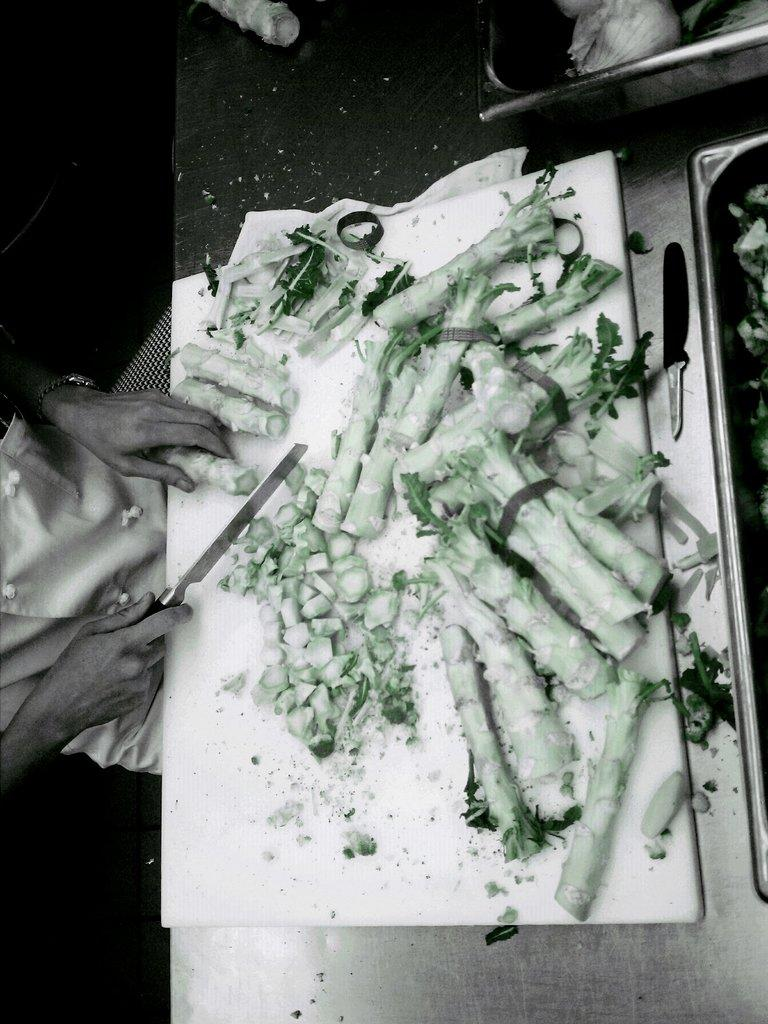What is the person in the image doing? The person is cutting vegetables. What surface is the person using to cut the vegetables? The vegetables are on a cutting board. Where is the cutting board located? The cutting board is on a table in the image. What else can be seen on the table? There are objects on the table. What type of pin can be seen holding the vegetables together in the image? There is no pin present in the image; the vegetables are on a cutting board and the person is cutting them. 